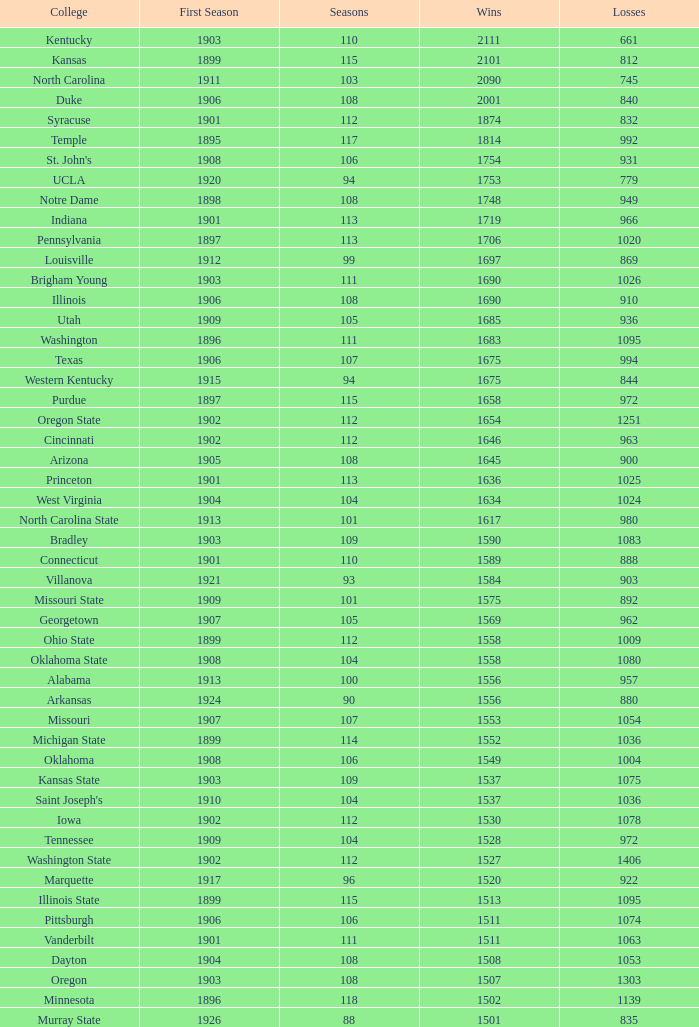What is the sum of first season matches with 1537 victories and a season exceeding 109? None. 